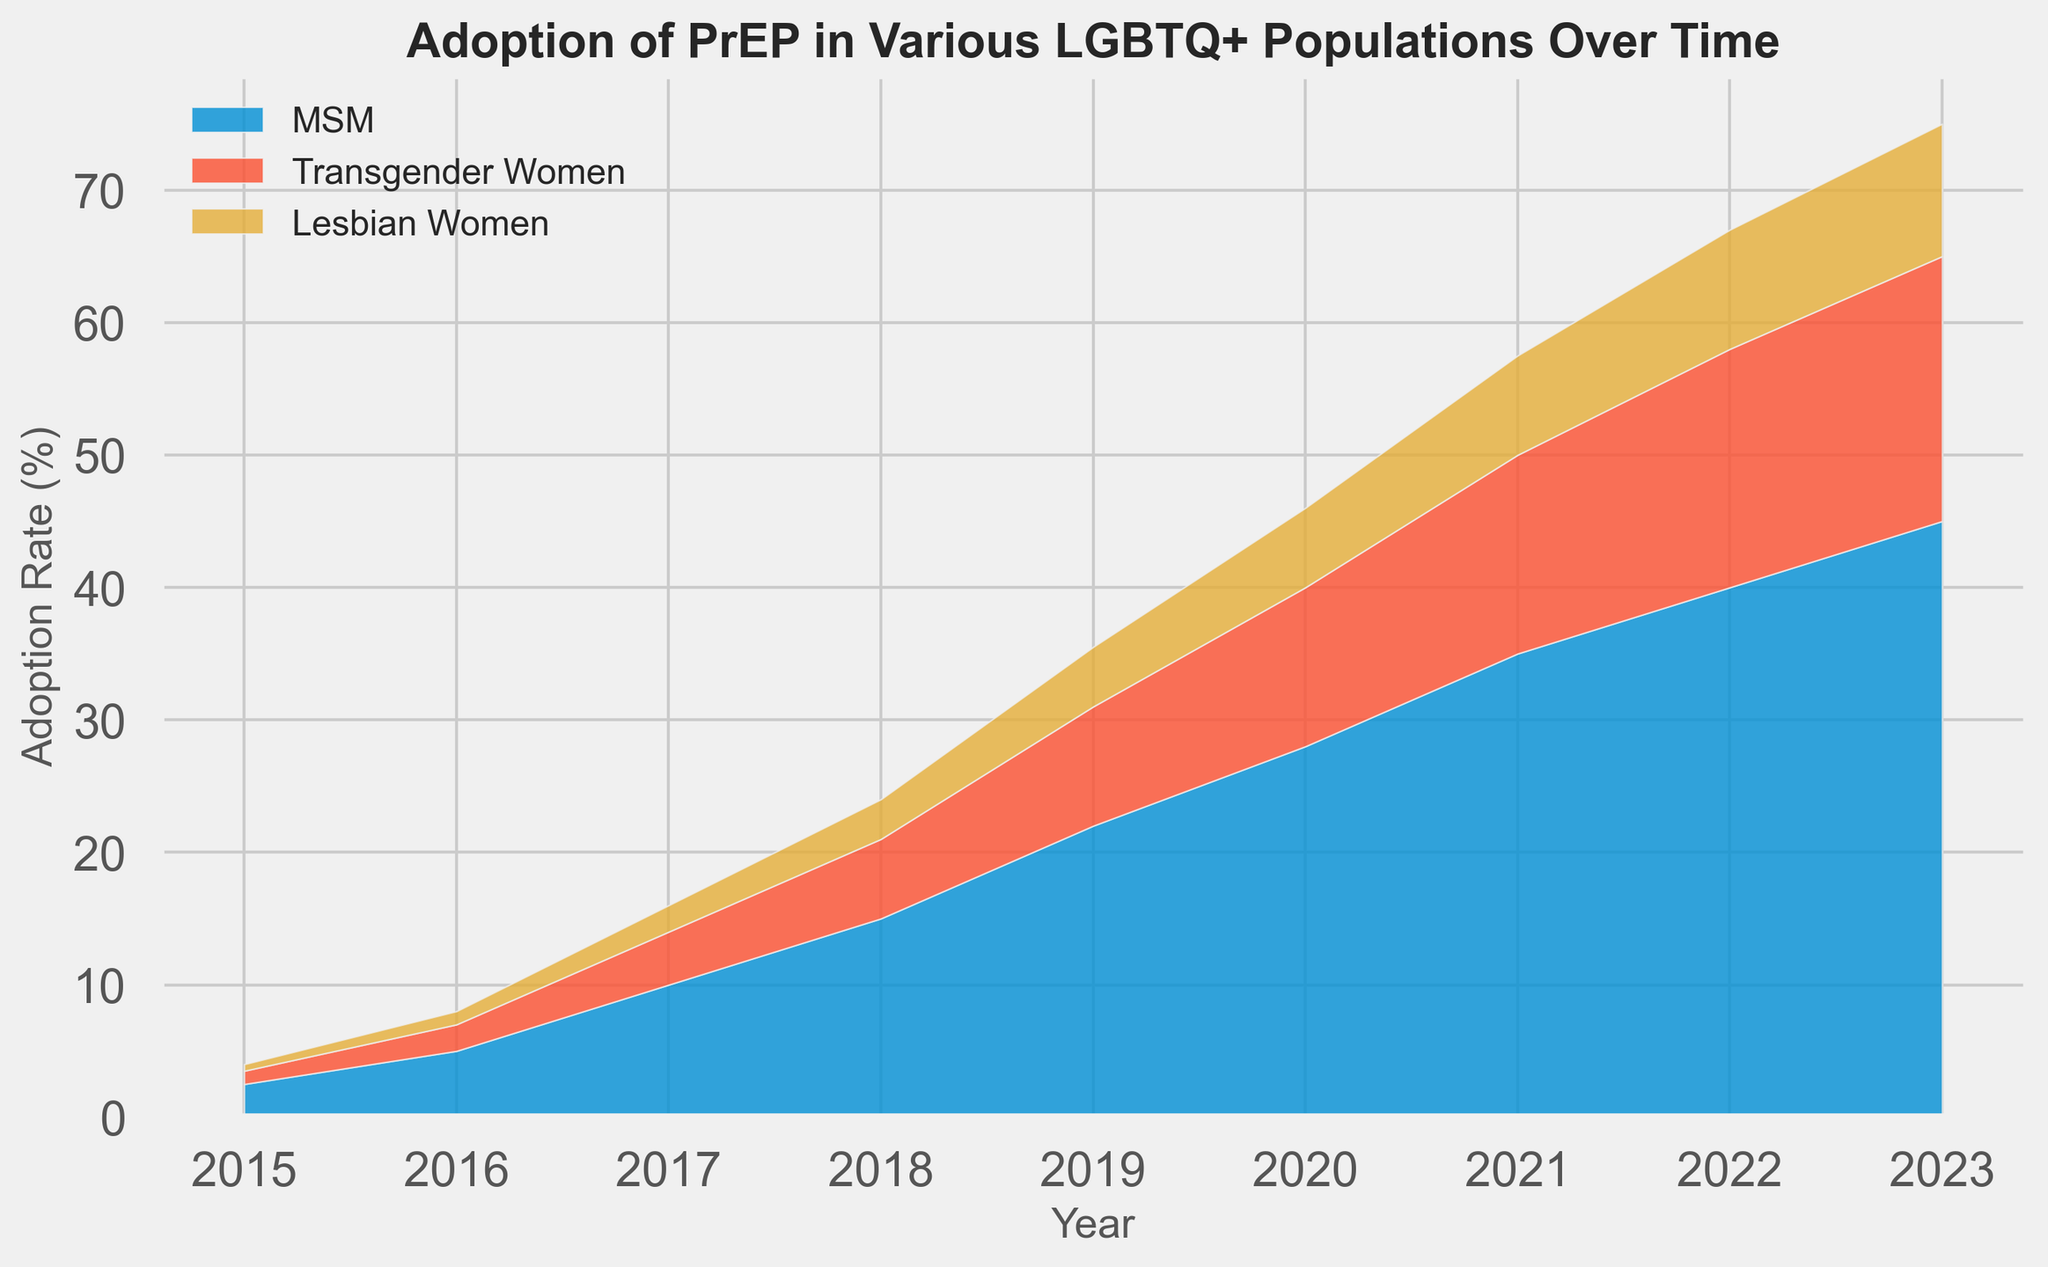What is the difference in the adoption rate of PrEP for MSM between 2015 and 2023? First, locate the adoption rate for MSM in 2015 which is 2.5%, and in 2023 which is 45%. Subtract the two values to get the difference: 45 - 2.5 = 42.5
Answer: 42.5 Which population had the highest PrEP adoption rate in 2023? Check the adoption rates in 2023 across the MSM, Transgender Women, and Lesbian Women populations. MSM has 45%, Transgender Women has 20%, and Lesbian Women has 10%. The highest among these is MSM with 45%
Answer: MSM Between which years did the adoption rate for Transgender Women double for the first time? Look for when the adoption rate for Transgender Women first doubled. It was 2% in 2016 and doubled to 4% in 2017. So, the years are 2016 to 2017.
Answer: 2016 to 2017 What is the sum of the adoption rates for MSM, Transgender Women, and Lesbian Women in 2020? Locate the adoption rates for all three populations in 2020: MSM (28%), Transgender Women (12%), and Lesbian Women (6%). Sum these values: 28 + 12 + 6 = 46
Answer: 46 How does the adoption rate for Transgender Women visually compare with the adoption rate for MSM over the period of 2015-2023? Visually, the area representing MSM is consistently larger and grows more rapidly compared to the area for Transgender Women, indicating a higher adoption rate for MSM throughout the period
Answer: MSM adoption rate is higher In which years did the adoption rate for Lesbian Women increase by exactly 50% from the previous year? Identify the rates: (2015 to 2016) 0.5 to 1.0 is a 100% increase, (2016 to 2017) 1.0 to 2.0 is a 100% increase, (2017 to 2018) 2.0 to 3.0 is a 50% increase, (2018 to 2019) 3.0 to 4.5 is a 50% increase. Therefore, the correct years are 2017 to 2018 and 2018 to 2019.
Answer: 2017 to 2018 and 2018 to 2019 What is the average adoption rate of PrEP for MSM over the period of 2015-2023? Locate the yearly adoption rates for MSM: 2.5, 5.0, 10.0, 15.0, 22.0, 28.0, 35.0, 40.0, 45.0. Sum these values: 2.5 + 5.0 + 10.0 + 15.0 + 22.0 + 28.0 + 35.0 + 40.0 + 45.0 = 202.5. Divide by the number of years: 202.5 / 9 ≈ 22.5
Answer: 22.5 